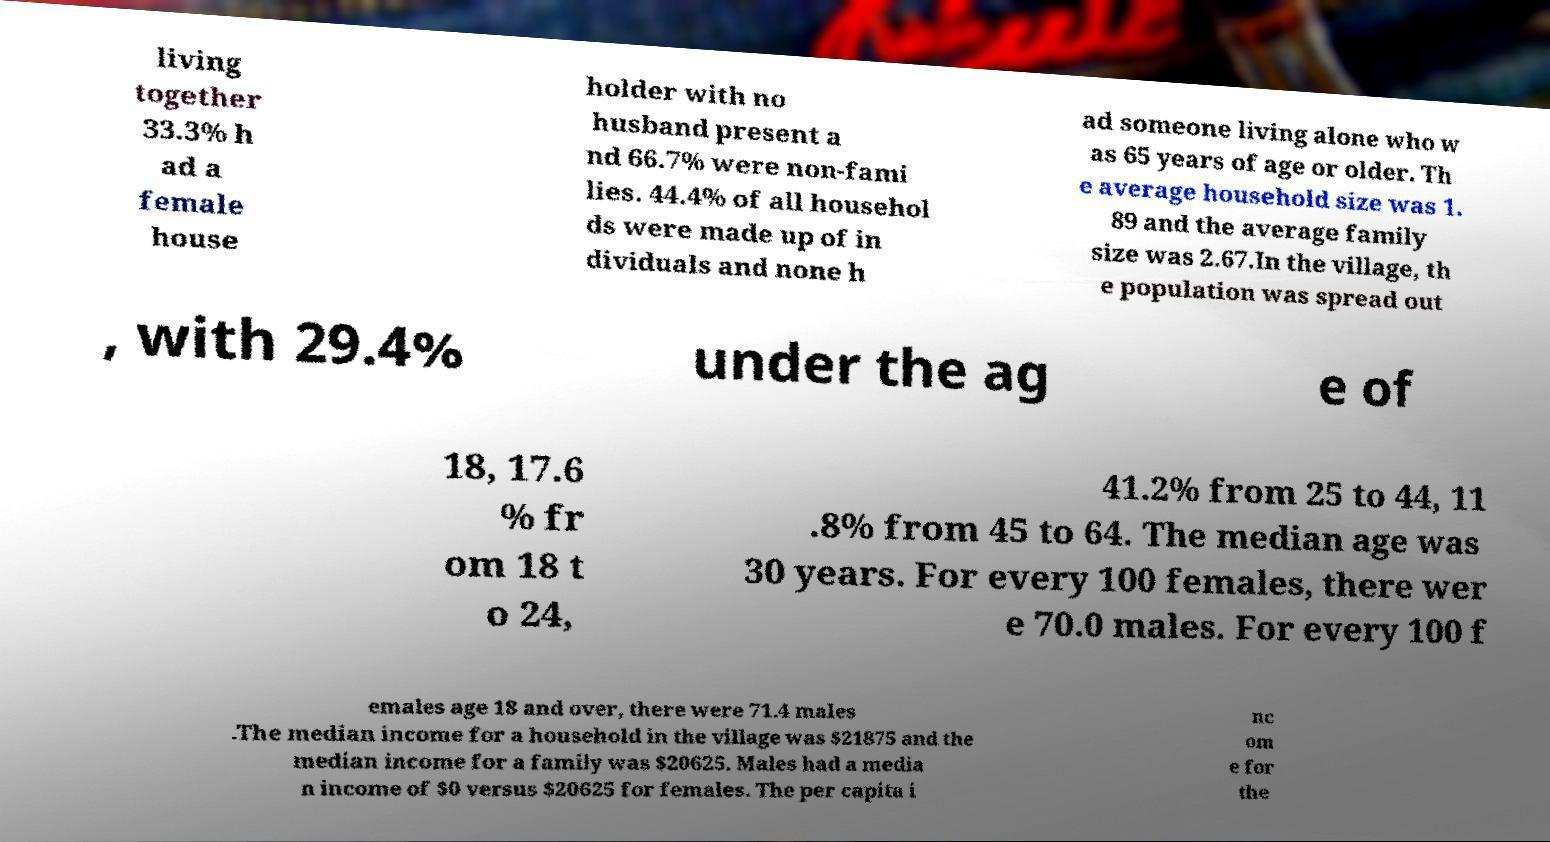What messages or text are displayed in this image? I need them in a readable, typed format. living together 33.3% h ad a female house holder with no husband present a nd 66.7% were non-fami lies. 44.4% of all househol ds were made up of in dividuals and none h ad someone living alone who w as 65 years of age or older. Th e average household size was 1. 89 and the average family size was 2.67.In the village, th e population was spread out , with 29.4% under the ag e of 18, 17.6 % fr om 18 t o 24, 41.2% from 25 to 44, 11 .8% from 45 to 64. The median age was 30 years. For every 100 females, there wer e 70.0 males. For every 100 f emales age 18 and over, there were 71.4 males .The median income for a household in the village was $21875 and the median income for a family was $20625. Males had a media n income of $0 versus $20625 for females. The per capita i nc om e for the 